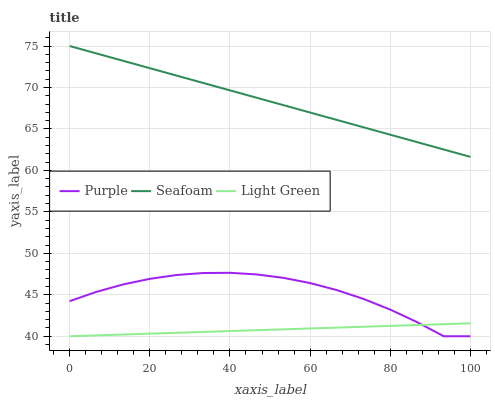Does Light Green have the minimum area under the curve?
Answer yes or no. Yes. Does Seafoam have the maximum area under the curve?
Answer yes or no. Yes. Does Seafoam have the minimum area under the curve?
Answer yes or no. No. Does Light Green have the maximum area under the curve?
Answer yes or no. No. Is Light Green the smoothest?
Answer yes or no. Yes. Is Purple the roughest?
Answer yes or no. Yes. Is Seafoam the smoothest?
Answer yes or no. No. Is Seafoam the roughest?
Answer yes or no. No. Does Purple have the lowest value?
Answer yes or no. Yes. Does Seafoam have the lowest value?
Answer yes or no. No. Does Seafoam have the highest value?
Answer yes or no. Yes. Does Light Green have the highest value?
Answer yes or no. No. Is Light Green less than Seafoam?
Answer yes or no. Yes. Is Seafoam greater than Purple?
Answer yes or no. Yes. Does Light Green intersect Purple?
Answer yes or no. Yes. Is Light Green less than Purple?
Answer yes or no. No. Is Light Green greater than Purple?
Answer yes or no. No. Does Light Green intersect Seafoam?
Answer yes or no. No. 